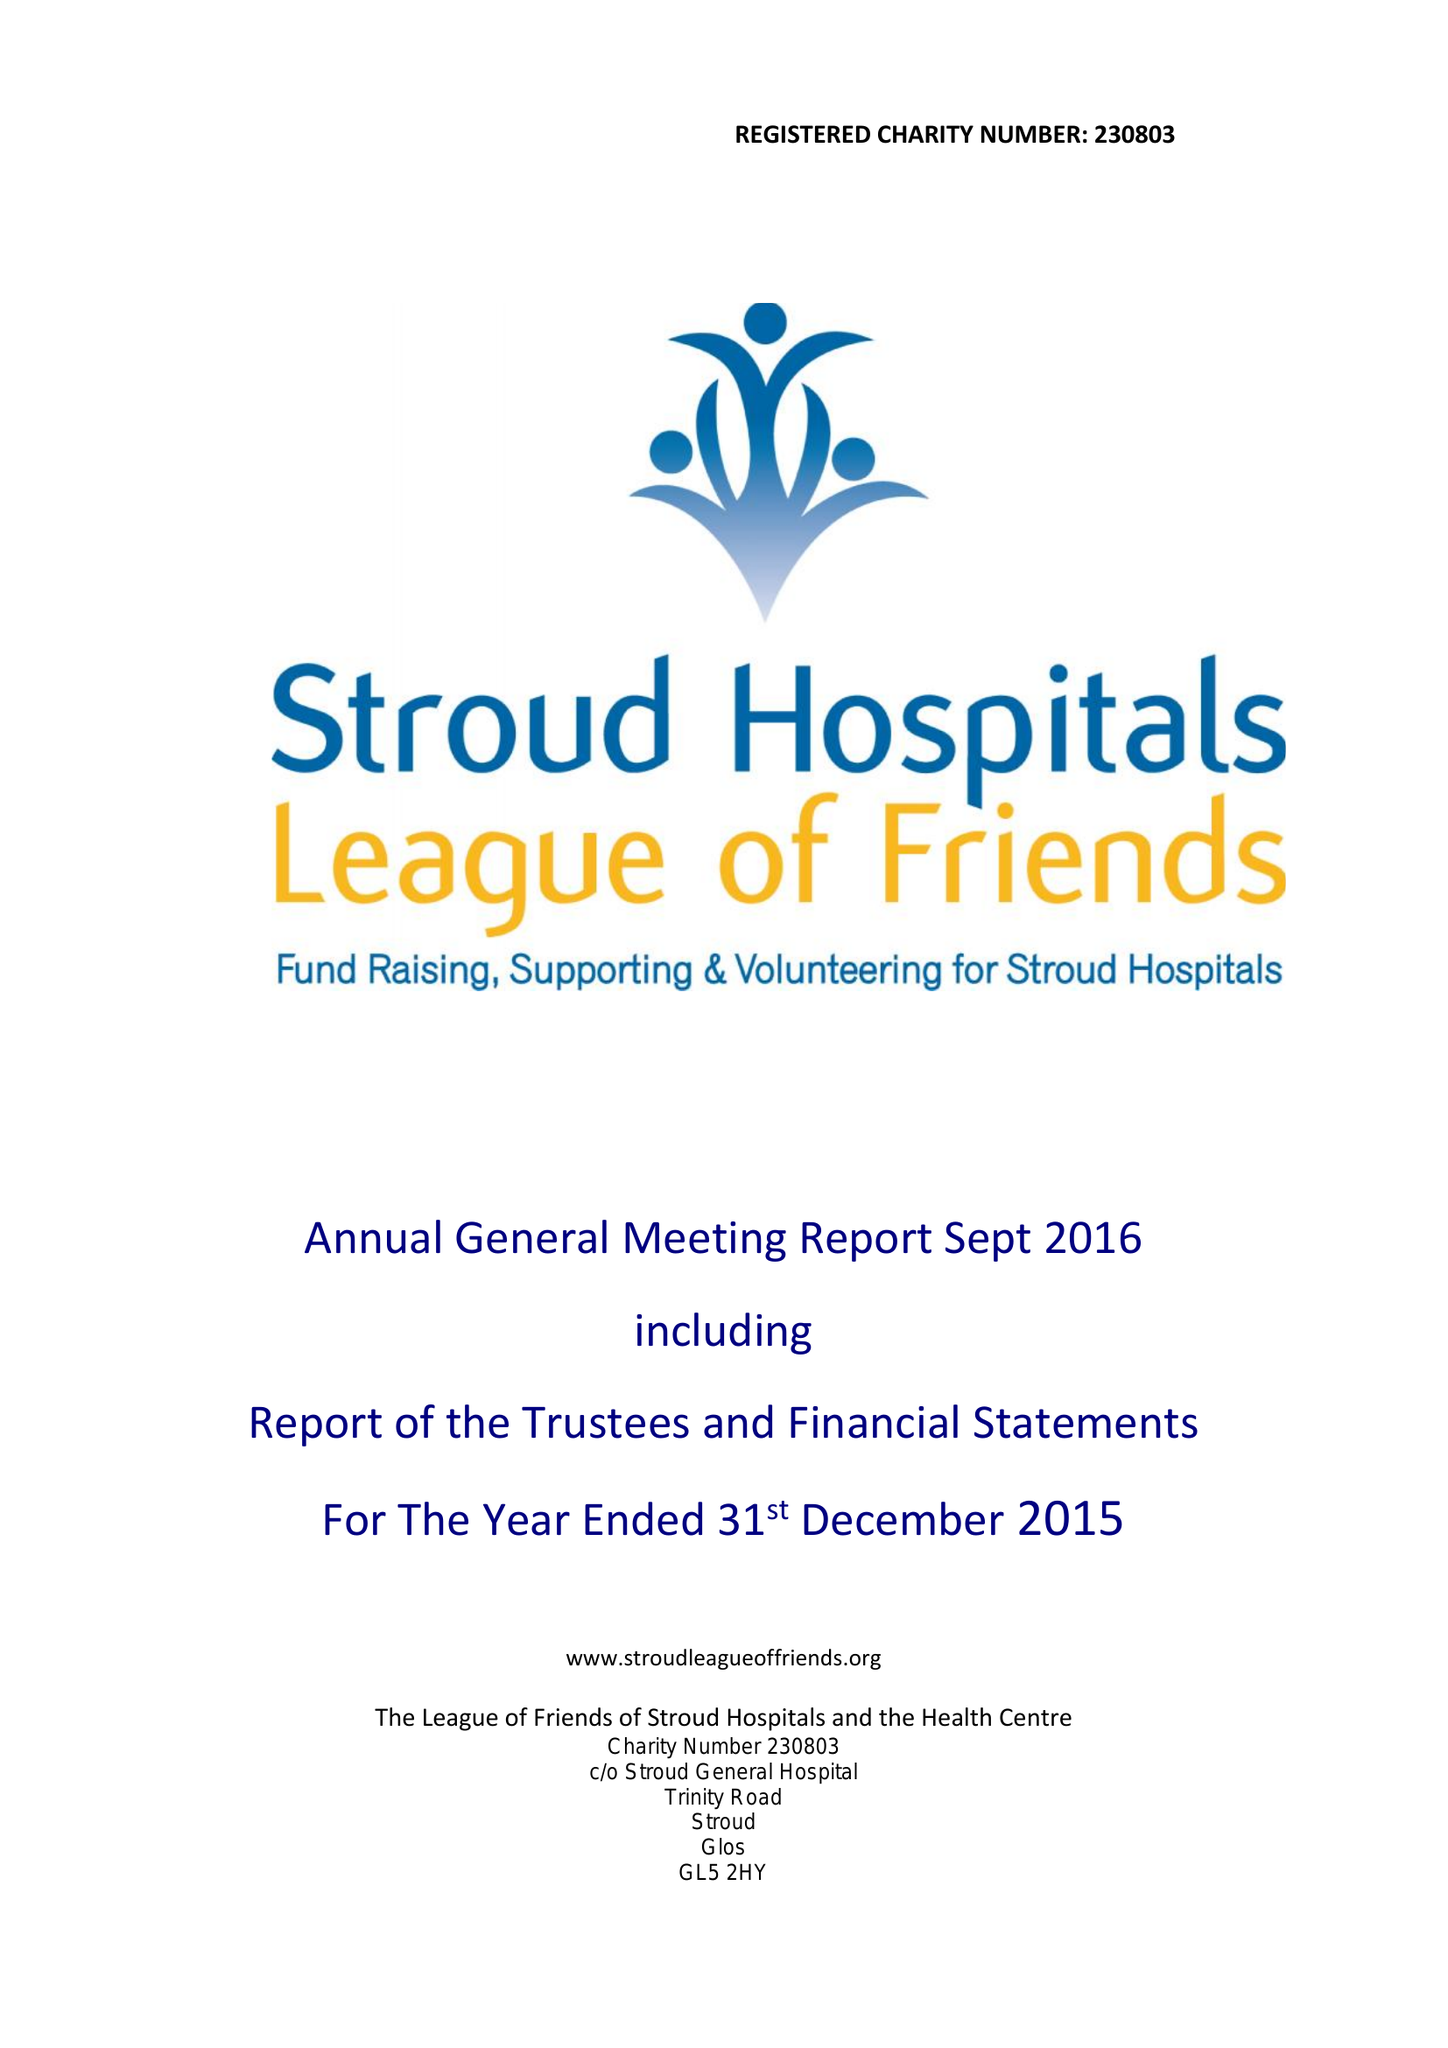What is the value for the charity_name?
Answer the question using a single word or phrase. The League Of Friends Of Stroud Hospitals and The Health Centre 